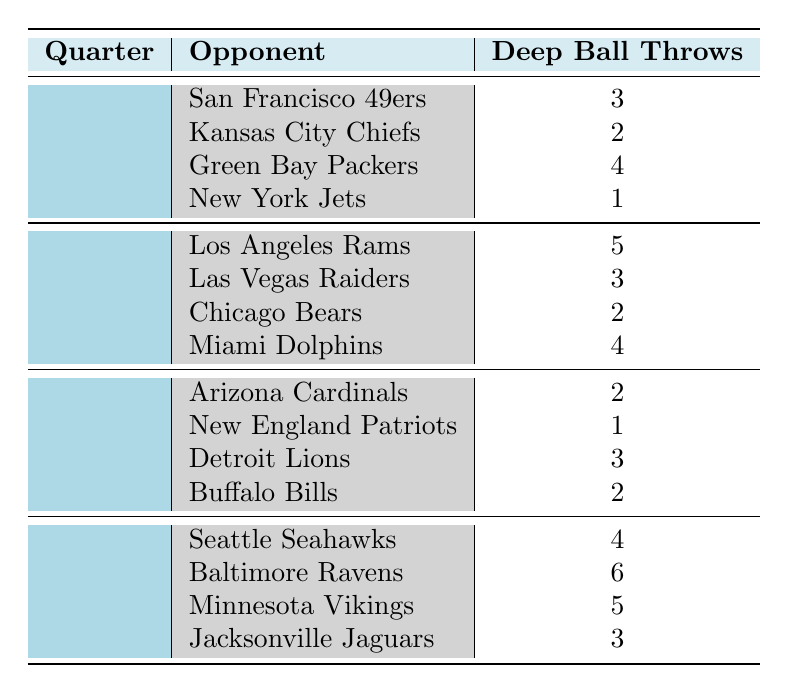What is the total number of deep ball throws by Russell Wilson in the 2nd quarter? To answer this, we look at the number of deep ball throws in the 2nd quarter across all opponents: Los Angeles Rams (5), Las Vegas Raiders (3), Chicago Bears (2), and Miami Dolphins (4). Adding these together gives us 5 + 3 + 2 + 4 = 14.
Answer: 14 Which opponent did Russell Wilson throw the most deep balls against in the 4th quarter? In the 4th quarter, we observe the deep ball throws against four opponents: Seattle Seahawks (4), Baltimore Ravens (6), Minnesota Vikings (5), and Jacksonville Jaguars (3). The highest number is 6 against the Baltimore Ravens.
Answer: Baltimore Ravens How many deep ball throws did Russell Wilson make in total across all quarters? We need to sum the deep ball throws from all quarters and opponents. Adding them up: (3+2+4+1) + (5+3+2+4) + (2+1+3+2) + (4+6+5+3) gives us a total of 3 + 2 + 4 + 1 + 5 + 3 + 2 + 4 + 2 + 1 + 3 + 2 + 4 + 6 + 5 + 3 = 54.
Answer: 54 Was there ever a game where Russell Wilson did not throw any deep balls? Assessing the data, we can see that in all the provided games, the lowest number of deep ball throws is 1 (against New York Jets in the 1st quarter), which indicates he always attempted at least one deep ball. Therefore, there was never a game with zero deep balls.
Answer: No Which quarter had the highest average deep ball throws per game? First, we calculate the average for each quarter. 1st quarter: (3+2+4+1) / 4 = 2.5, 2nd quarter: (5+3+2+4) / 4 = 3.5, 3rd quarter: (2+1+3+2) / 4 = 2, and 4th quarter: (4+6+5+3) / 4 = 4. The highest average is 4 in the 4th quarter.
Answer: 4 How did the number of deep ball throws in the 1st quarter compare to those in the 3rd quarter? We will sum up the deep ball throws in each quarter. In the 1st quarter, the total is 3 + 2 + 4 + 1 = 10, and in the 3rd quarter, the total is 2 + 1 + 3 + 2 = 8. Comparing these, the 1st quarter (10) has more deep ball throws than the 3rd quarter (8).
Answer: 1st quarter has more (10 vs 8) 